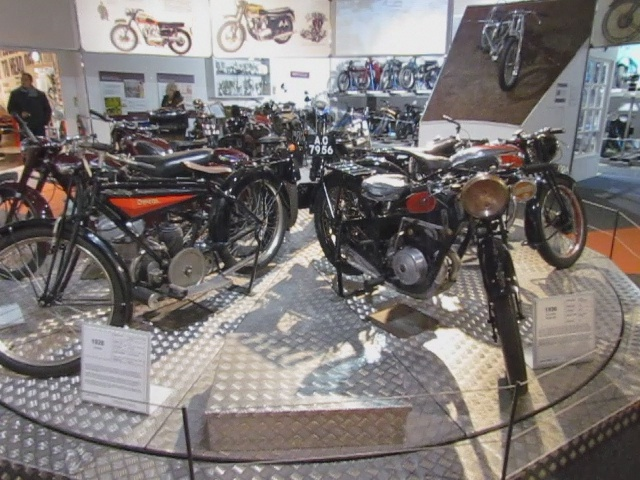Describe the objects in this image and their specific colors. I can see motorcycle in gray, black, darkgray, and maroon tones, motorcycle in gray, black, darkgray, and maroon tones, motorcycle in gray, black, and darkgray tones, motorcycle in gray, black, maroon, and darkgray tones, and motorcycle in gray, darkgray, and lightgray tones in this image. 